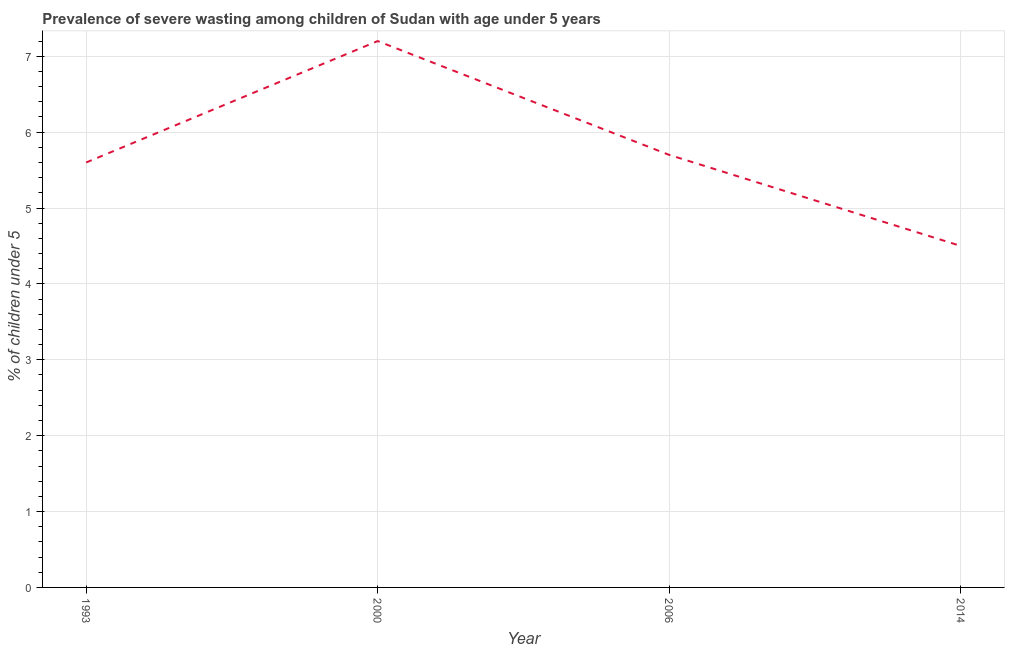What is the prevalence of severe wasting in 1993?
Offer a terse response. 5.6. Across all years, what is the maximum prevalence of severe wasting?
Your response must be concise. 7.2. In which year was the prevalence of severe wasting maximum?
Provide a short and direct response. 2000. What is the sum of the prevalence of severe wasting?
Keep it short and to the point. 23. What is the difference between the prevalence of severe wasting in 1993 and 2000?
Ensure brevity in your answer.  -1.6. What is the average prevalence of severe wasting per year?
Make the answer very short. 5.75. What is the median prevalence of severe wasting?
Offer a terse response. 5.65. In how many years, is the prevalence of severe wasting greater than 0.4 %?
Your answer should be compact. 4. Do a majority of the years between 1993 and 2000 (inclusive) have prevalence of severe wasting greater than 2.8 %?
Ensure brevity in your answer.  Yes. What is the ratio of the prevalence of severe wasting in 1993 to that in 2000?
Your answer should be compact. 0.78. Is the prevalence of severe wasting in 1993 less than that in 2014?
Make the answer very short. No. Is the difference between the prevalence of severe wasting in 2000 and 2006 greater than the difference between any two years?
Give a very brief answer. No. What is the difference between the highest and the second highest prevalence of severe wasting?
Provide a short and direct response. 1.5. Is the sum of the prevalence of severe wasting in 2000 and 2014 greater than the maximum prevalence of severe wasting across all years?
Give a very brief answer. Yes. What is the difference between the highest and the lowest prevalence of severe wasting?
Provide a short and direct response. 2.7. In how many years, is the prevalence of severe wasting greater than the average prevalence of severe wasting taken over all years?
Offer a very short reply. 1. How many lines are there?
Give a very brief answer. 1. Are the values on the major ticks of Y-axis written in scientific E-notation?
Ensure brevity in your answer.  No. Does the graph contain any zero values?
Offer a terse response. No. What is the title of the graph?
Offer a very short reply. Prevalence of severe wasting among children of Sudan with age under 5 years. What is the label or title of the Y-axis?
Your answer should be very brief.  % of children under 5. What is the  % of children under 5 of 1993?
Provide a short and direct response. 5.6. What is the  % of children under 5 in 2000?
Make the answer very short. 7.2. What is the  % of children under 5 in 2006?
Provide a succinct answer. 5.7. What is the difference between the  % of children under 5 in 1993 and 2006?
Offer a terse response. -0.1. What is the difference between the  % of children under 5 in 2000 and 2006?
Your answer should be compact. 1.5. What is the ratio of the  % of children under 5 in 1993 to that in 2000?
Give a very brief answer. 0.78. What is the ratio of the  % of children under 5 in 1993 to that in 2006?
Provide a short and direct response. 0.98. What is the ratio of the  % of children under 5 in 1993 to that in 2014?
Give a very brief answer. 1.24. What is the ratio of the  % of children under 5 in 2000 to that in 2006?
Keep it short and to the point. 1.26. What is the ratio of the  % of children under 5 in 2006 to that in 2014?
Give a very brief answer. 1.27. 